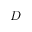Convert formula to latex. <formula><loc_0><loc_0><loc_500><loc_500>D</formula> 